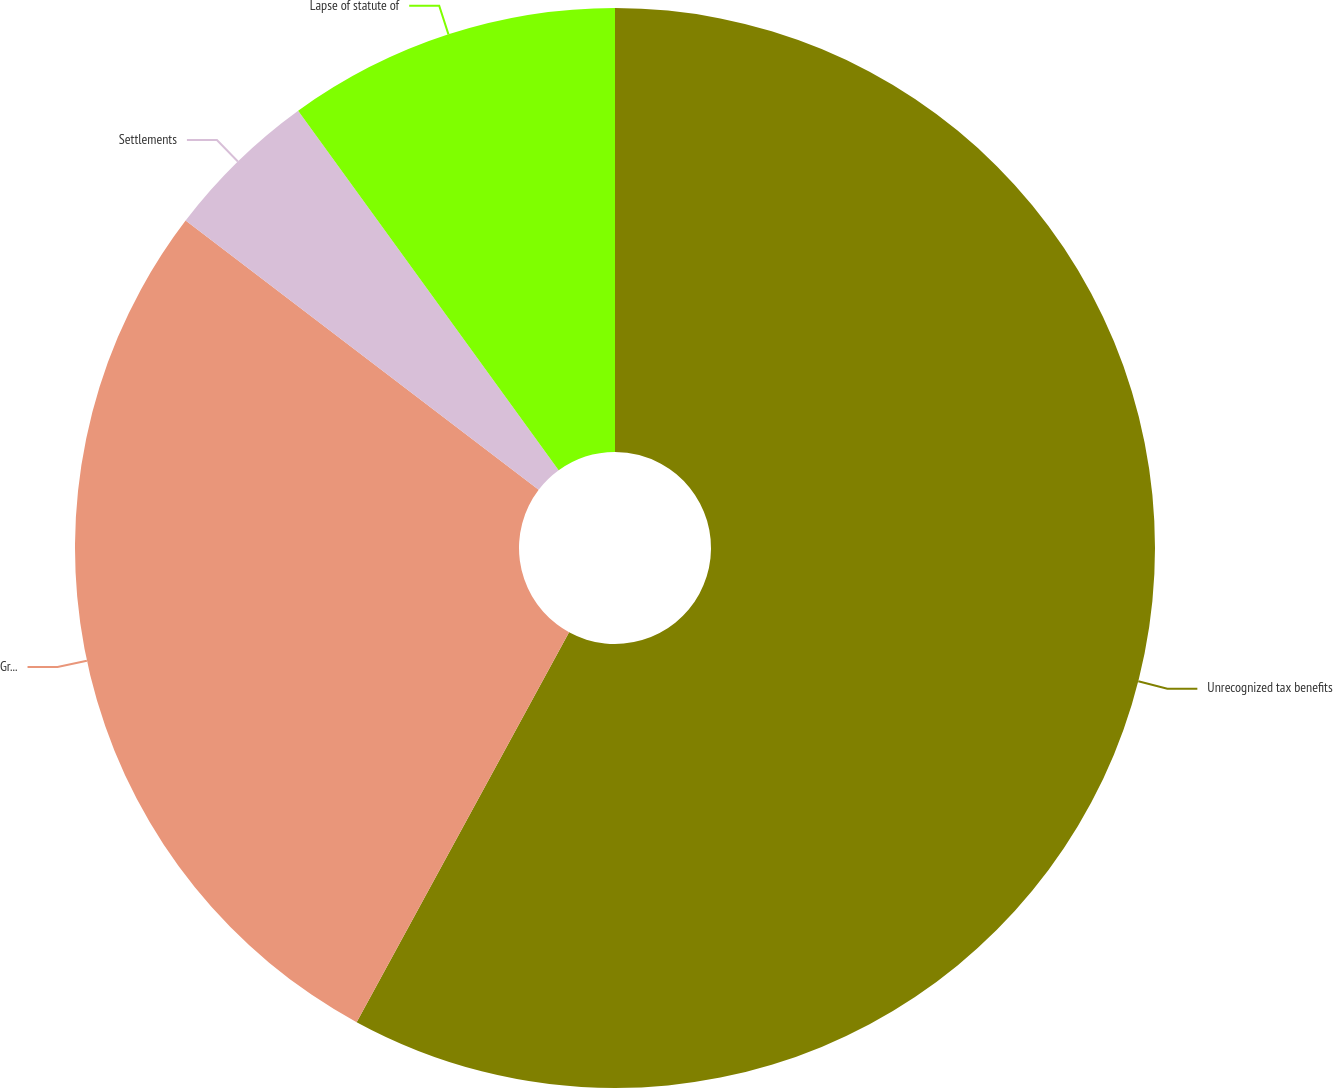Convert chart to OTSL. <chart><loc_0><loc_0><loc_500><loc_500><pie_chart><fcel>Unrecognized tax benefits<fcel>Gross increases for tax<fcel>Settlements<fcel>Lapse of statute of<nl><fcel>57.94%<fcel>27.43%<fcel>4.65%<fcel>9.98%<nl></chart> 